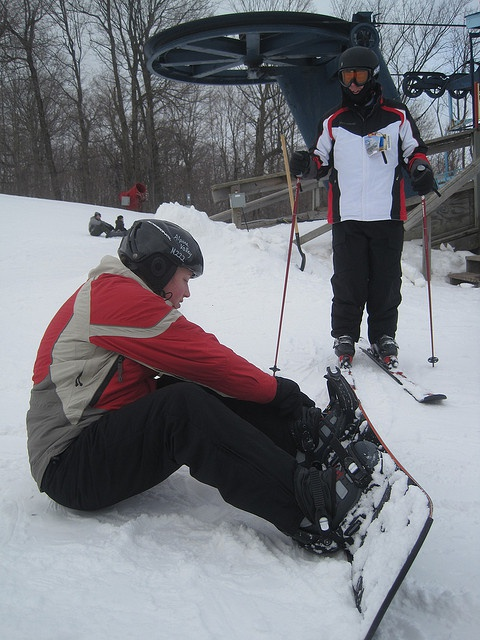Describe the objects in this image and their specific colors. I can see people in black, gray, maroon, and brown tones, people in black, darkgray, and gray tones, snowboard in black, lightgray, and darkgray tones, skis in black, lightgray, darkgray, and gray tones, and people in black, gray, and purple tones in this image. 